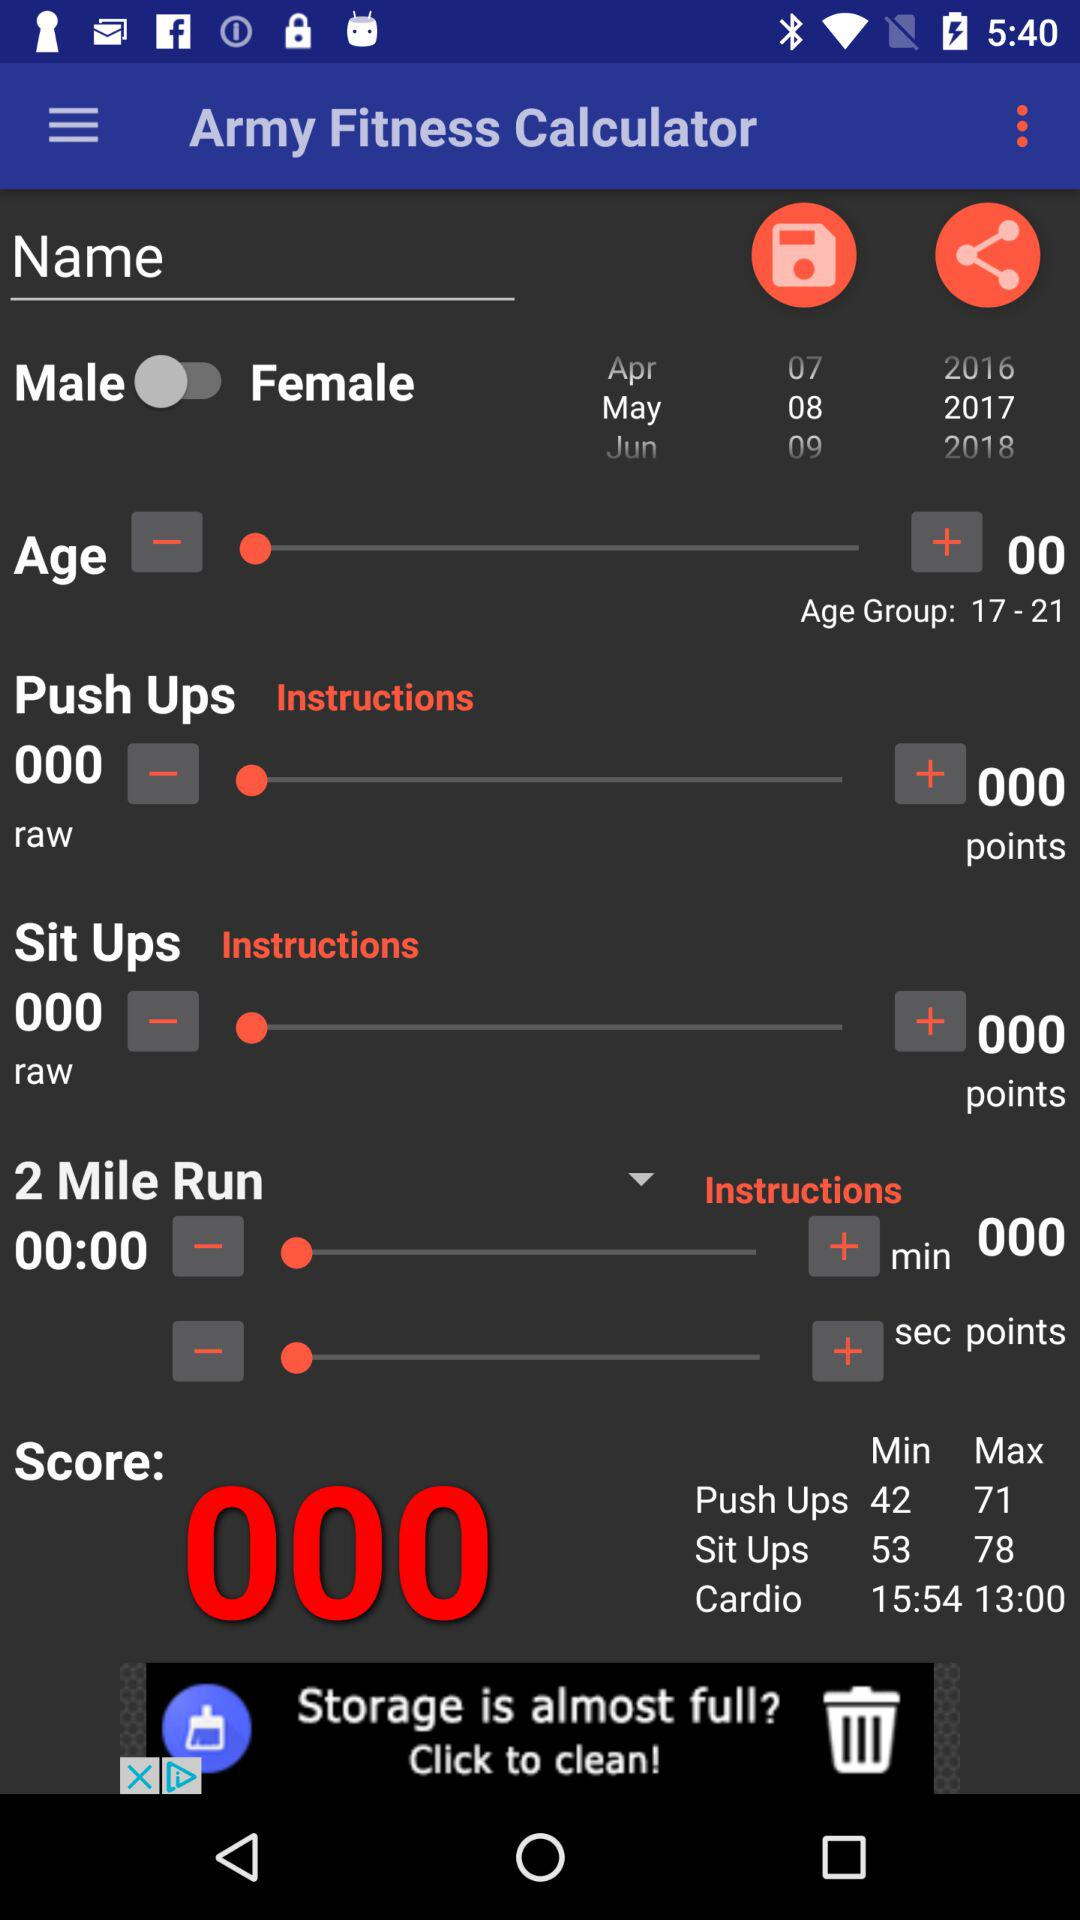What is the gender? The gender is male. 